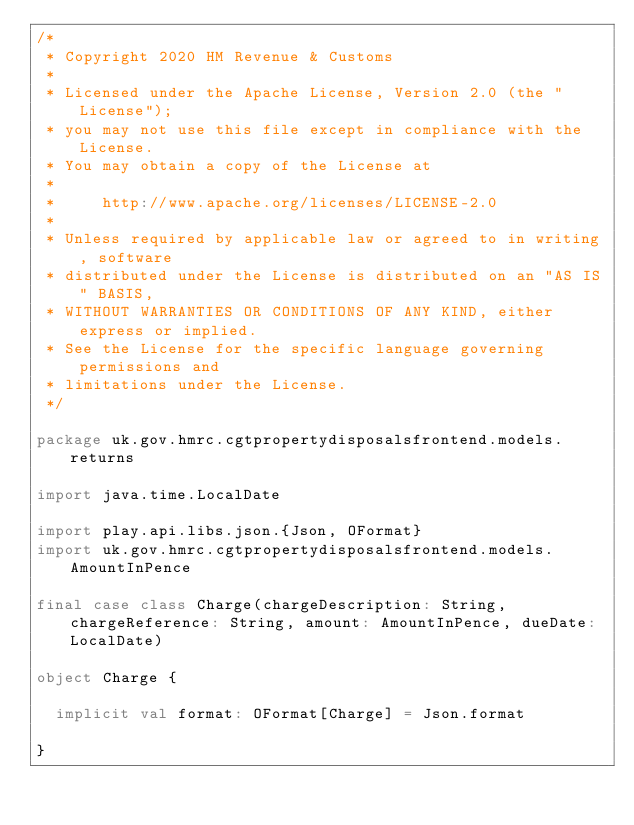<code> <loc_0><loc_0><loc_500><loc_500><_Scala_>/*
 * Copyright 2020 HM Revenue & Customs
 *
 * Licensed under the Apache License, Version 2.0 (the "License");
 * you may not use this file except in compliance with the License.
 * You may obtain a copy of the License at
 *
 *     http://www.apache.org/licenses/LICENSE-2.0
 *
 * Unless required by applicable law or agreed to in writing, software
 * distributed under the License is distributed on an "AS IS" BASIS,
 * WITHOUT WARRANTIES OR CONDITIONS OF ANY KIND, either express or implied.
 * See the License for the specific language governing permissions and
 * limitations under the License.
 */

package uk.gov.hmrc.cgtpropertydisposalsfrontend.models.returns

import java.time.LocalDate

import play.api.libs.json.{Json, OFormat}
import uk.gov.hmrc.cgtpropertydisposalsfrontend.models.AmountInPence

final case class Charge(chargeDescription: String, chargeReference: String, amount: AmountInPence, dueDate: LocalDate)

object Charge {

  implicit val format: OFormat[Charge] = Json.format

}
</code> 